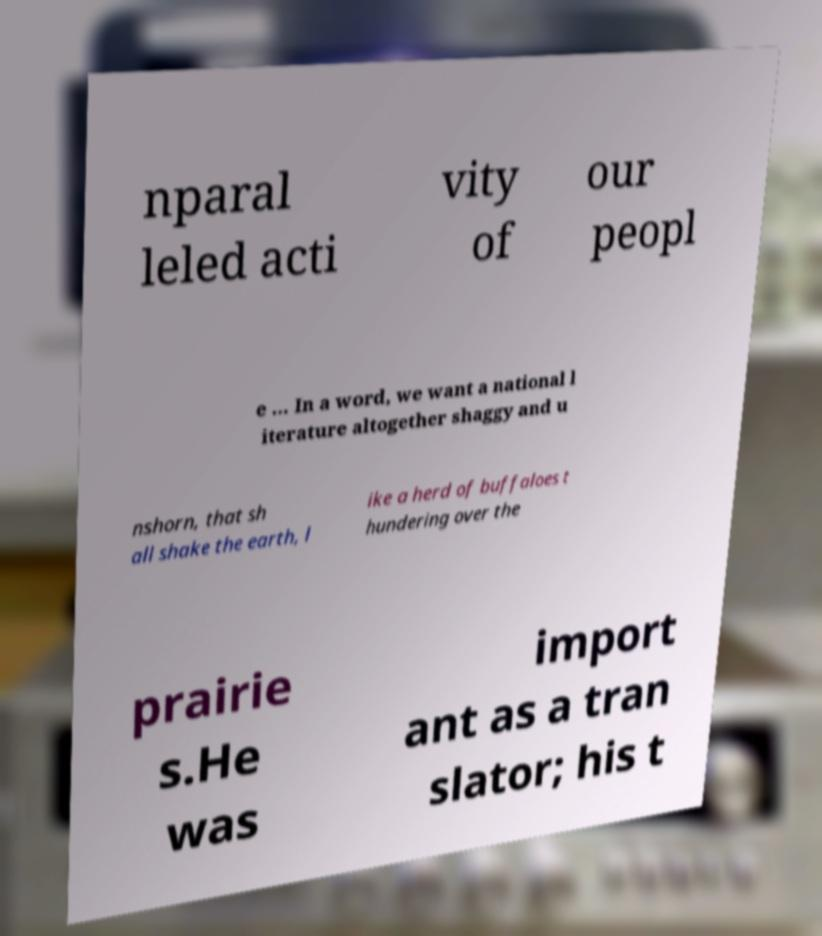For documentation purposes, I need the text within this image transcribed. Could you provide that? nparal leled acti vity of our peopl e ... In a word, we want a national l iterature altogether shaggy and u nshorn, that sh all shake the earth, l ike a herd of buffaloes t hundering over the prairie s.He was import ant as a tran slator; his t 